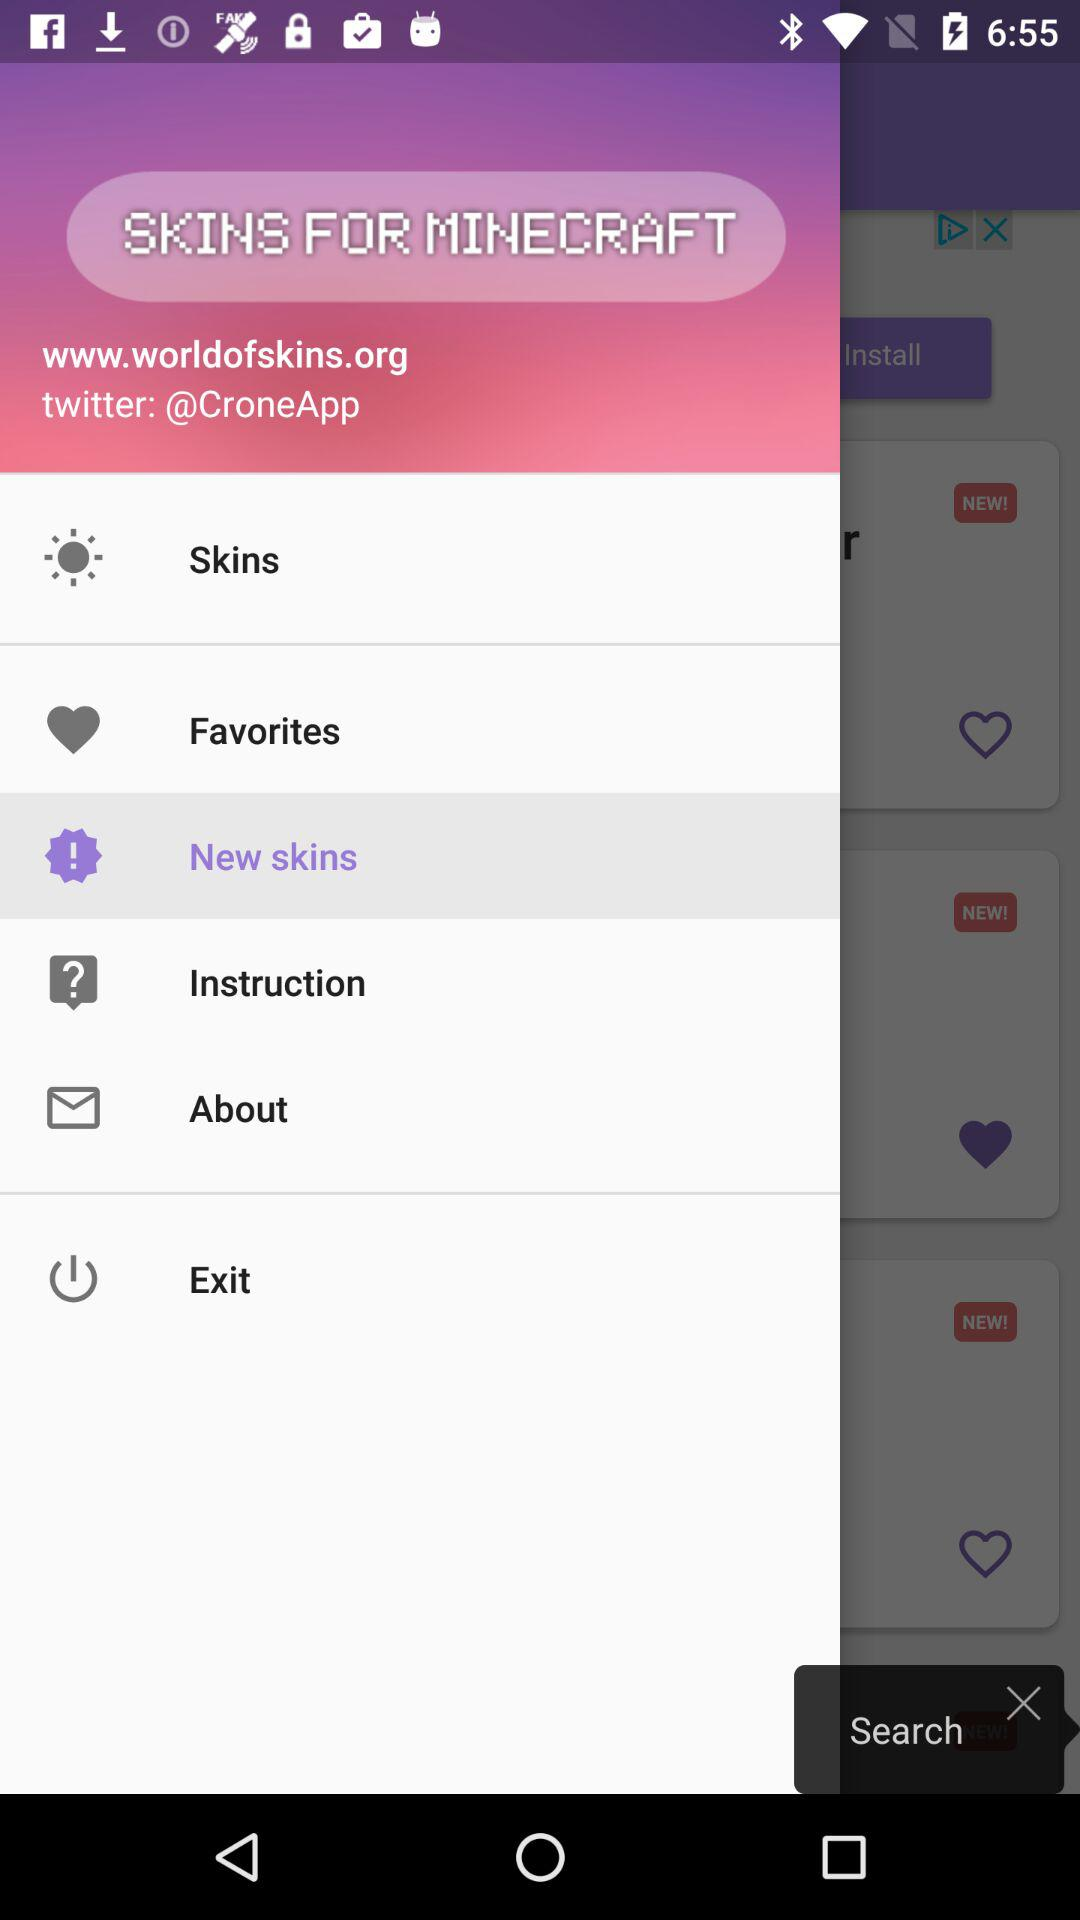What's the web address of the application? The web address of the application is www.worldofskins.org. 